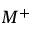<formula> <loc_0><loc_0><loc_500><loc_500>M ^ { + }</formula> 